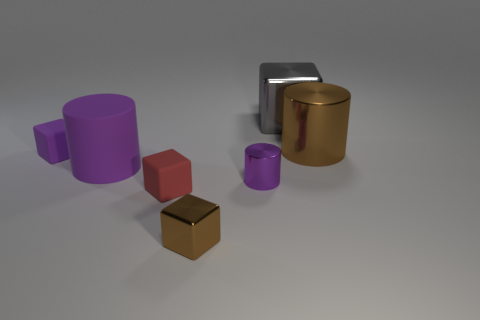Could you describe the spatial arrangement of the objects? Certainly! In the image, we observe a collection of geometric shapes arranged with a sense of balance. A golden metallic cylinder stands to the right, with a purple metallic cylinder on the left, slightly behind it. Two cubes, one gray and one in a shade of bronze, rest in front. Completing the scene, a small purple rubber cylinder lies to the side, facing the camera at an angle. 